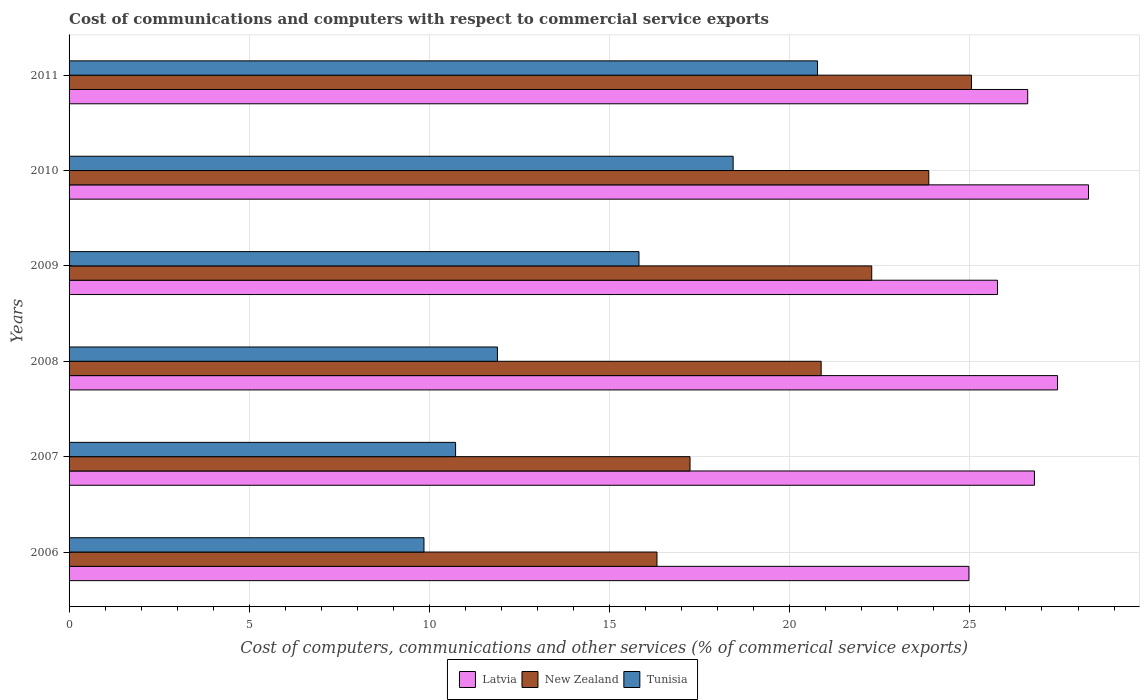How many groups of bars are there?
Your response must be concise. 6. Are the number of bars per tick equal to the number of legend labels?
Offer a very short reply. Yes. Are the number of bars on each tick of the Y-axis equal?
Your answer should be very brief. Yes. How many bars are there on the 5th tick from the top?
Provide a short and direct response. 3. What is the label of the 4th group of bars from the top?
Your answer should be compact. 2008. In how many cases, is the number of bars for a given year not equal to the number of legend labels?
Make the answer very short. 0. What is the cost of communications and computers in Tunisia in 2009?
Provide a succinct answer. 15.82. Across all years, what is the maximum cost of communications and computers in New Zealand?
Your response must be concise. 25.04. Across all years, what is the minimum cost of communications and computers in New Zealand?
Provide a succinct answer. 16.32. What is the total cost of communications and computers in Tunisia in the graph?
Provide a short and direct response. 87.48. What is the difference between the cost of communications and computers in New Zealand in 2006 and that in 2009?
Make the answer very short. -5.96. What is the difference between the cost of communications and computers in Latvia in 2011 and the cost of communications and computers in Tunisia in 2008?
Your answer should be very brief. 14.72. What is the average cost of communications and computers in New Zealand per year?
Offer a very short reply. 20.93. In the year 2009, what is the difference between the cost of communications and computers in New Zealand and cost of communications and computers in Latvia?
Offer a very short reply. -3.49. In how many years, is the cost of communications and computers in Latvia greater than 5 %?
Provide a short and direct response. 6. What is the ratio of the cost of communications and computers in Tunisia in 2006 to that in 2009?
Your answer should be compact. 0.62. What is the difference between the highest and the second highest cost of communications and computers in New Zealand?
Provide a short and direct response. 1.18. What is the difference between the highest and the lowest cost of communications and computers in Tunisia?
Provide a succinct answer. 10.92. What does the 3rd bar from the top in 2007 represents?
Make the answer very short. Latvia. What does the 3rd bar from the bottom in 2007 represents?
Keep it short and to the point. Tunisia. Is it the case that in every year, the sum of the cost of communications and computers in Latvia and cost of communications and computers in Tunisia is greater than the cost of communications and computers in New Zealand?
Give a very brief answer. Yes. Are all the bars in the graph horizontal?
Provide a short and direct response. Yes. How many years are there in the graph?
Give a very brief answer. 6. Are the values on the major ticks of X-axis written in scientific E-notation?
Provide a succinct answer. No. Does the graph contain any zero values?
Keep it short and to the point. No. Does the graph contain grids?
Offer a very short reply. Yes. Where does the legend appear in the graph?
Your response must be concise. Bottom center. How many legend labels are there?
Provide a succinct answer. 3. How are the legend labels stacked?
Offer a very short reply. Horizontal. What is the title of the graph?
Provide a succinct answer. Cost of communications and computers with respect to commercial service exports. What is the label or title of the X-axis?
Make the answer very short. Cost of computers, communications and other services (% of commerical service exports). What is the Cost of computers, communications and other services (% of commerical service exports) of Latvia in 2006?
Ensure brevity in your answer.  24.97. What is the Cost of computers, communications and other services (% of commerical service exports) of New Zealand in 2006?
Offer a terse response. 16.32. What is the Cost of computers, communications and other services (% of commerical service exports) in Tunisia in 2006?
Your answer should be compact. 9.85. What is the Cost of computers, communications and other services (% of commerical service exports) of Latvia in 2007?
Give a very brief answer. 26.79. What is the Cost of computers, communications and other services (% of commerical service exports) of New Zealand in 2007?
Provide a succinct answer. 17.23. What is the Cost of computers, communications and other services (% of commerical service exports) of Tunisia in 2007?
Offer a very short reply. 10.73. What is the Cost of computers, communications and other services (% of commerical service exports) of Latvia in 2008?
Offer a very short reply. 27.43. What is the Cost of computers, communications and other services (% of commerical service exports) in New Zealand in 2008?
Keep it short and to the point. 20.87. What is the Cost of computers, communications and other services (% of commerical service exports) of Tunisia in 2008?
Your answer should be very brief. 11.89. What is the Cost of computers, communications and other services (% of commerical service exports) in Latvia in 2009?
Your answer should be very brief. 25.77. What is the Cost of computers, communications and other services (% of commerical service exports) of New Zealand in 2009?
Provide a succinct answer. 22.28. What is the Cost of computers, communications and other services (% of commerical service exports) of Tunisia in 2009?
Give a very brief answer. 15.82. What is the Cost of computers, communications and other services (% of commerical service exports) in Latvia in 2010?
Make the answer very short. 28.29. What is the Cost of computers, communications and other services (% of commerical service exports) of New Zealand in 2010?
Offer a terse response. 23.86. What is the Cost of computers, communications and other services (% of commerical service exports) in Tunisia in 2010?
Offer a very short reply. 18.43. What is the Cost of computers, communications and other services (% of commerical service exports) of Latvia in 2011?
Give a very brief answer. 26.6. What is the Cost of computers, communications and other services (% of commerical service exports) in New Zealand in 2011?
Make the answer very short. 25.04. What is the Cost of computers, communications and other services (% of commerical service exports) of Tunisia in 2011?
Your answer should be very brief. 20.77. Across all years, what is the maximum Cost of computers, communications and other services (% of commerical service exports) in Latvia?
Your answer should be compact. 28.29. Across all years, what is the maximum Cost of computers, communications and other services (% of commerical service exports) in New Zealand?
Provide a succinct answer. 25.04. Across all years, what is the maximum Cost of computers, communications and other services (% of commerical service exports) of Tunisia?
Offer a very short reply. 20.77. Across all years, what is the minimum Cost of computers, communications and other services (% of commerical service exports) of Latvia?
Make the answer very short. 24.97. Across all years, what is the minimum Cost of computers, communications and other services (% of commerical service exports) in New Zealand?
Offer a terse response. 16.32. Across all years, what is the minimum Cost of computers, communications and other services (% of commerical service exports) in Tunisia?
Ensure brevity in your answer.  9.85. What is the total Cost of computers, communications and other services (% of commerical service exports) of Latvia in the graph?
Offer a very short reply. 159.86. What is the total Cost of computers, communications and other services (% of commerical service exports) in New Zealand in the graph?
Offer a terse response. 125.6. What is the total Cost of computers, communications and other services (% of commerical service exports) in Tunisia in the graph?
Provide a succinct answer. 87.48. What is the difference between the Cost of computers, communications and other services (% of commerical service exports) in Latvia in 2006 and that in 2007?
Your response must be concise. -1.82. What is the difference between the Cost of computers, communications and other services (% of commerical service exports) of New Zealand in 2006 and that in 2007?
Provide a succinct answer. -0.92. What is the difference between the Cost of computers, communications and other services (% of commerical service exports) in Tunisia in 2006 and that in 2007?
Offer a very short reply. -0.88. What is the difference between the Cost of computers, communications and other services (% of commerical service exports) in Latvia in 2006 and that in 2008?
Keep it short and to the point. -2.46. What is the difference between the Cost of computers, communications and other services (% of commerical service exports) of New Zealand in 2006 and that in 2008?
Ensure brevity in your answer.  -4.56. What is the difference between the Cost of computers, communications and other services (% of commerical service exports) in Tunisia in 2006 and that in 2008?
Offer a terse response. -2.04. What is the difference between the Cost of computers, communications and other services (% of commerical service exports) in Latvia in 2006 and that in 2009?
Provide a succinct answer. -0.79. What is the difference between the Cost of computers, communications and other services (% of commerical service exports) in New Zealand in 2006 and that in 2009?
Make the answer very short. -5.96. What is the difference between the Cost of computers, communications and other services (% of commerical service exports) of Tunisia in 2006 and that in 2009?
Your answer should be very brief. -5.97. What is the difference between the Cost of computers, communications and other services (% of commerical service exports) of Latvia in 2006 and that in 2010?
Your answer should be compact. -3.32. What is the difference between the Cost of computers, communications and other services (% of commerical service exports) in New Zealand in 2006 and that in 2010?
Offer a terse response. -7.54. What is the difference between the Cost of computers, communications and other services (% of commerical service exports) in Tunisia in 2006 and that in 2010?
Provide a succinct answer. -8.58. What is the difference between the Cost of computers, communications and other services (% of commerical service exports) of Latvia in 2006 and that in 2011?
Your answer should be compact. -1.63. What is the difference between the Cost of computers, communications and other services (% of commerical service exports) in New Zealand in 2006 and that in 2011?
Your answer should be very brief. -8.73. What is the difference between the Cost of computers, communications and other services (% of commerical service exports) of Tunisia in 2006 and that in 2011?
Your answer should be compact. -10.92. What is the difference between the Cost of computers, communications and other services (% of commerical service exports) of Latvia in 2007 and that in 2008?
Make the answer very short. -0.64. What is the difference between the Cost of computers, communications and other services (% of commerical service exports) in New Zealand in 2007 and that in 2008?
Make the answer very short. -3.64. What is the difference between the Cost of computers, communications and other services (% of commerical service exports) of Tunisia in 2007 and that in 2008?
Your response must be concise. -1.16. What is the difference between the Cost of computers, communications and other services (% of commerical service exports) of Latvia in 2007 and that in 2009?
Make the answer very short. 1.03. What is the difference between the Cost of computers, communications and other services (% of commerical service exports) of New Zealand in 2007 and that in 2009?
Your answer should be compact. -5.04. What is the difference between the Cost of computers, communications and other services (% of commerical service exports) of Tunisia in 2007 and that in 2009?
Your answer should be compact. -5.09. What is the difference between the Cost of computers, communications and other services (% of commerical service exports) of Latvia in 2007 and that in 2010?
Ensure brevity in your answer.  -1.5. What is the difference between the Cost of computers, communications and other services (% of commerical service exports) of New Zealand in 2007 and that in 2010?
Keep it short and to the point. -6.63. What is the difference between the Cost of computers, communications and other services (% of commerical service exports) of Tunisia in 2007 and that in 2010?
Your answer should be compact. -7.7. What is the difference between the Cost of computers, communications and other services (% of commerical service exports) of Latvia in 2007 and that in 2011?
Ensure brevity in your answer.  0.19. What is the difference between the Cost of computers, communications and other services (% of commerical service exports) in New Zealand in 2007 and that in 2011?
Give a very brief answer. -7.81. What is the difference between the Cost of computers, communications and other services (% of commerical service exports) of Tunisia in 2007 and that in 2011?
Keep it short and to the point. -10.04. What is the difference between the Cost of computers, communications and other services (% of commerical service exports) in Latvia in 2008 and that in 2009?
Provide a succinct answer. 1.67. What is the difference between the Cost of computers, communications and other services (% of commerical service exports) in New Zealand in 2008 and that in 2009?
Give a very brief answer. -1.4. What is the difference between the Cost of computers, communications and other services (% of commerical service exports) of Tunisia in 2008 and that in 2009?
Make the answer very short. -3.93. What is the difference between the Cost of computers, communications and other services (% of commerical service exports) in Latvia in 2008 and that in 2010?
Keep it short and to the point. -0.86. What is the difference between the Cost of computers, communications and other services (% of commerical service exports) in New Zealand in 2008 and that in 2010?
Make the answer very short. -2.99. What is the difference between the Cost of computers, communications and other services (% of commerical service exports) in Tunisia in 2008 and that in 2010?
Offer a terse response. -6.54. What is the difference between the Cost of computers, communications and other services (% of commerical service exports) of Latvia in 2008 and that in 2011?
Your response must be concise. 0.83. What is the difference between the Cost of computers, communications and other services (% of commerical service exports) of New Zealand in 2008 and that in 2011?
Ensure brevity in your answer.  -4.17. What is the difference between the Cost of computers, communications and other services (% of commerical service exports) of Tunisia in 2008 and that in 2011?
Give a very brief answer. -8.88. What is the difference between the Cost of computers, communications and other services (% of commerical service exports) in Latvia in 2009 and that in 2010?
Offer a very short reply. -2.53. What is the difference between the Cost of computers, communications and other services (% of commerical service exports) of New Zealand in 2009 and that in 2010?
Keep it short and to the point. -1.58. What is the difference between the Cost of computers, communications and other services (% of commerical service exports) in Tunisia in 2009 and that in 2010?
Give a very brief answer. -2.61. What is the difference between the Cost of computers, communications and other services (% of commerical service exports) of Latvia in 2009 and that in 2011?
Keep it short and to the point. -0.84. What is the difference between the Cost of computers, communications and other services (% of commerical service exports) in New Zealand in 2009 and that in 2011?
Your answer should be very brief. -2.77. What is the difference between the Cost of computers, communications and other services (% of commerical service exports) of Tunisia in 2009 and that in 2011?
Your response must be concise. -4.95. What is the difference between the Cost of computers, communications and other services (% of commerical service exports) of Latvia in 2010 and that in 2011?
Your response must be concise. 1.69. What is the difference between the Cost of computers, communications and other services (% of commerical service exports) of New Zealand in 2010 and that in 2011?
Your answer should be very brief. -1.18. What is the difference between the Cost of computers, communications and other services (% of commerical service exports) of Tunisia in 2010 and that in 2011?
Make the answer very short. -2.34. What is the difference between the Cost of computers, communications and other services (% of commerical service exports) in Latvia in 2006 and the Cost of computers, communications and other services (% of commerical service exports) in New Zealand in 2007?
Provide a short and direct response. 7.74. What is the difference between the Cost of computers, communications and other services (% of commerical service exports) in Latvia in 2006 and the Cost of computers, communications and other services (% of commerical service exports) in Tunisia in 2007?
Offer a terse response. 14.25. What is the difference between the Cost of computers, communications and other services (% of commerical service exports) in New Zealand in 2006 and the Cost of computers, communications and other services (% of commerical service exports) in Tunisia in 2007?
Your response must be concise. 5.59. What is the difference between the Cost of computers, communications and other services (% of commerical service exports) in Latvia in 2006 and the Cost of computers, communications and other services (% of commerical service exports) in New Zealand in 2008?
Make the answer very short. 4.1. What is the difference between the Cost of computers, communications and other services (% of commerical service exports) in Latvia in 2006 and the Cost of computers, communications and other services (% of commerical service exports) in Tunisia in 2008?
Keep it short and to the point. 13.09. What is the difference between the Cost of computers, communications and other services (% of commerical service exports) of New Zealand in 2006 and the Cost of computers, communications and other services (% of commerical service exports) of Tunisia in 2008?
Give a very brief answer. 4.43. What is the difference between the Cost of computers, communications and other services (% of commerical service exports) of Latvia in 2006 and the Cost of computers, communications and other services (% of commerical service exports) of New Zealand in 2009?
Ensure brevity in your answer.  2.7. What is the difference between the Cost of computers, communications and other services (% of commerical service exports) in Latvia in 2006 and the Cost of computers, communications and other services (% of commerical service exports) in Tunisia in 2009?
Offer a very short reply. 9.16. What is the difference between the Cost of computers, communications and other services (% of commerical service exports) of New Zealand in 2006 and the Cost of computers, communications and other services (% of commerical service exports) of Tunisia in 2009?
Offer a very short reply. 0.5. What is the difference between the Cost of computers, communications and other services (% of commerical service exports) in Latvia in 2006 and the Cost of computers, communications and other services (% of commerical service exports) in New Zealand in 2010?
Make the answer very short. 1.11. What is the difference between the Cost of computers, communications and other services (% of commerical service exports) in Latvia in 2006 and the Cost of computers, communications and other services (% of commerical service exports) in Tunisia in 2010?
Provide a succinct answer. 6.54. What is the difference between the Cost of computers, communications and other services (% of commerical service exports) in New Zealand in 2006 and the Cost of computers, communications and other services (% of commerical service exports) in Tunisia in 2010?
Keep it short and to the point. -2.11. What is the difference between the Cost of computers, communications and other services (% of commerical service exports) in Latvia in 2006 and the Cost of computers, communications and other services (% of commerical service exports) in New Zealand in 2011?
Keep it short and to the point. -0.07. What is the difference between the Cost of computers, communications and other services (% of commerical service exports) of Latvia in 2006 and the Cost of computers, communications and other services (% of commerical service exports) of Tunisia in 2011?
Provide a succinct answer. 4.2. What is the difference between the Cost of computers, communications and other services (% of commerical service exports) in New Zealand in 2006 and the Cost of computers, communications and other services (% of commerical service exports) in Tunisia in 2011?
Your answer should be compact. -4.46. What is the difference between the Cost of computers, communications and other services (% of commerical service exports) of Latvia in 2007 and the Cost of computers, communications and other services (% of commerical service exports) of New Zealand in 2008?
Offer a terse response. 5.92. What is the difference between the Cost of computers, communications and other services (% of commerical service exports) of Latvia in 2007 and the Cost of computers, communications and other services (% of commerical service exports) of Tunisia in 2008?
Offer a terse response. 14.9. What is the difference between the Cost of computers, communications and other services (% of commerical service exports) in New Zealand in 2007 and the Cost of computers, communications and other services (% of commerical service exports) in Tunisia in 2008?
Offer a terse response. 5.35. What is the difference between the Cost of computers, communications and other services (% of commerical service exports) of Latvia in 2007 and the Cost of computers, communications and other services (% of commerical service exports) of New Zealand in 2009?
Provide a succinct answer. 4.52. What is the difference between the Cost of computers, communications and other services (% of commerical service exports) of Latvia in 2007 and the Cost of computers, communications and other services (% of commerical service exports) of Tunisia in 2009?
Offer a terse response. 10.98. What is the difference between the Cost of computers, communications and other services (% of commerical service exports) of New Zealand in 2007 and the Cost of computers, communications and other services (% of commerical service exports) of Tunisia in 2009?
Provide a succinct answer. 1.42. What is the difference between the Cost of computers, communications and other services (% of commerical service exports) in Latvia in 2007 and the Cost of computers, communications and other services (% of commerical service exports) in New Zealand in 2010?
Your response must be concise. 2.93. What is the difference between the Cost of computers, communications and other services (% of commerical service exports) in Latvia in 2007 and the Cost of computers, communications and other services (% of commerical service exports) in Tunisia in 2010?
Offer a terse response. 8.36. What is the difference between the Cost of computers, communications and other services (% of commerical service exports) in New Zealand in 2007 and the Cost of computers, communications and other services (% of commerical service exports) in Tunisia in 2010?
Ensure brevity in your answer.  -1.2. What is the difference between the Cost of computers, communications and other services (% of commerical service exports) of Latvia in 2007 and the Cost of computers, communications and other services (% of commerical service exports) of New Zealand in 2011?
Offer a terse response. 1.75. What is the difference between the Cost of computers, communications and other services (% of commerical service exports) in Latvia in 2007 and the Cost of computers, communications and other services (% of commerical service exports) in Tunisia in 2011?
Offer a terse response. 6.02. What is the difference between the Cost of computers, communications and other services (% of commerical service exports) in New Zealand in 2007 and the Cost of computers, communications and other services (% of commerical service exports) in Tunisia in 2011?
Give a very brief answer. -3.54. What is the difference between the Cost of computers, communications and other services (% of commerical service exports) of Latvia in 2008 and the Cost of computers, communications and other services (% of commerical service exports) of New Zealand in 2009?
Offer a terse response. 5.16. What is the difference between the Cost of computers, communications and other services (% of commerical service exports) in Latvia in 2008 and the Cost of computers, communications and other services (% of commerical service exports) in Tunisia in 2009?
Offer a very short reply. 11.62. What is the difference between the Cost of computers, communications and other services (% of commerical service exports) in New Zealand in 2008 and the Cost of computers, communications and other services (% of commerical service exports) in Tunisia in 2009?
Provide a short and direct response. 5.06. What is the difference between the Cost of computers, communications and other services (% of commerical service exports) in Latvia in 2008 and the Cost of computers, communications and other services (% of commerical service exports) in New Zealand in 2010?
Provide a succinct answer. 3.57. What is the difference between the Cost of computers, communications and other services (% of commerical service exports) in Latvia in 2008 and the Cost of computers, communications and other services (% of commerical service exports) in Tunisia in 2010?
Keep it short and to the point. 9. What is the difference between the Cost of computers, communications and other services (% of commerical service exports) of New Zealand in 2008 and the Cost of computers, communications and other services (% of commerical service exports) of Tunisia in 2010?
Offer a terse response. 2.44. What is the difference between the Cost of computers, communications and other services (% of commerical service exports) in Latvia in 2008 and the Cost of computers, communications and other services (% of commerical service exports) in New Zealand in 2011?
Keep it short and to the point. 2.39. What is the difference between the Cost of computers, communications and other services (% of commerical service exports) in Latvia in 2008 and the Cost of computers, communications and other services (% of commerical service exports) in Tunisia in 2011?
Give a very brief answer. 6.66. What is the difference between the Cost of computers, communications and other services (% of commerical service exports) of New Zealand in 2008 and the Cost of computers, communications and other services (% of commerical service exports) of Tunisia in 2011?
Ensure brevity in your answer.  0.1. What is the difference between the Cost of computers, communications and other services (% of commerical service exports) in Latvia in 2009 and the Cost of computers, communications and other services (% of commerical service exports) in New Zealand in 2010?
Provide a short and direct response. 1.91. What is the difference between the Cost of computers, communications and other services (% of commerical service exports) in Latvia in 2009 and the Cost of computers, communications and other services (% of commerical service exports) in Tunisia in 2010?
Your response must be concise. 7.34. What is the difference between the Cost of computers, communications and other services (% of commerical service exports) of New Zealand in 2009 and the Cost of computers, communications and other services (% of commerical service exports) of Tunisia in 2010?
Give a very brief answer. 3.85. What is the difference between the Cost of computers, communications and other services (% of commerical service exports) of Latvia in 2009 and the Cost of computers, communications and other services (% of commerical service exports) of New Zealand in 2011?
Offer a terse response. 0.72. What is the difference between the Cost of computers, communications and other services (% of commerical service exports) of Latvia in 2009 and the Cost of computers, communications and other services (% of commerical service exports) of Tunisia in 2011?
Your answer should be very brief. 5. What is the difference between the Cost of computers, communications and other services (% of commerical service exports) of New Zealand in 2009 and the Cost of computers, communications and other services (% of commerical service exports) of Tunisia in 2011?
Offer a terse response. 1.5. What is the difference between the Cost of computers, communications and other services (% of commerical service exports) in Latvia in 2010 and the Cost of computers, communications and other services (% of commerical service exports) in New Zealand in 2011?
Your answer should be compact. 3.25. What is the difference between the Cost of computers, communications and other services (% of commerical service exports) of Latvia in 2010 and the Cost of computers, communications and other services (% of commerical service exports) of Tunisia in 2011?
Provide a succinct answer. 7.52. What is the difference between the Cost of computers, communications and other services (% of commerical service exports) in New Zealand in 2010 and the Cost of computers, communications and other services (% of commerical service exports) in Tunisia in 2011?
Provide a short and direct response. 3.09. What is the average Cost of computers, communications and other services (% of commerical service exports) in Latvia per year?
Your answer should be very brief. 26.64. What is the average Cost of computers, communications and other services (% of commerical service exports) of New Zealand per year?
Provide a short and direct response. 20.93. What is the average Cost of computers, communications and other services (% of commerical service exports) in Tunisia per year?
Your response must be concise. 14.58. In the year 2006, what is the difference between the Cost of computers, communications and other services (% of commerical service exports) of Latvia and Cost of computers, communications and other services (% of commerical service exports) of New Zealand?
Ensure brevity in your answer.  8.66. In the year 2006, what is the difference between the Cost of computers, communications and other services (% of commerical service exports) of Latvia and Cost of computers, communications and other services (% of commerical service exports) of Tunisia?
Ensure brevity in your answer.  15.12. In the year 2006, what is the difference between the Cost of computers, communications and other services (% of commerical service exports) in New Zealand and Cost of computers, communications and other services (% of commerical service exports) in Tunisia?
Offer a very short reply. 6.47. In the year 2007, what is the difference between the Cost of computers, communications and other services (% of commerical service exports) in Latvia and Cost of computers, communications and other services (% of commerical service exports) in New Zealand?
Offer a terse response. 9.56. In the year 2007, what is the difference between the Cost of computers, communications and other services (% of commerical service exports) of Latvia and Cost of computers, communications and other services (% of commerical service exports) of Tunisia?
Offer a terse response. 16.06. In the year 2007, what is the difference between the Cost of computers, communications and other services (% of commerical service exports) of New Zealand and Cost of computers, communications and other services (% of commerical service exports) of Tunisia?
Offer a very short reply. 6.51. In the year 2008, what is the difference between the Cost of computers, communications and other services (% of commerical service exports) of Latvia and Cost of computers, communications and other services (% of commerical service exports) of New Zealand?
Make the answer very short. 6.56. In the year 2008, what is the difference between the Cost of computers, communications and other services (% of commerical service exports) of Latvia and Cost of computers, communications and other services (% of commerical service exports) of Tunisia?
Keep it short and to the point. 15.54. In the year 2008, what is the difference between the Cost of computers, communications and other services (% of commerical service exports) in New Zealand and Cost of computers, communications and other services (% of commerical service exports) in Tunisia?
Offer a very short reply. 8.98. In the year 2009, what is the difference between the Cost of computers, communications and other services (% of commerical service exports) in Latvia and Cost of computers, communications and other services (% of commerical service exports) in New Zealand?
Your response must be concise. 3.49. In the year 2009, what is the difference between the Cost of computers, communications and other services (% of commerical service exports) of Latvia and Cost of computers, communications and other services (% of commerical service exports) of Tunisia?
Provide a short and direct response. 9.95. In the year 2009, what is the difference between the Cost of computers, communications and other services (% of commerical service exports) of New Zealand and Cost of computers, communications and other services (% of commerical service exports) of Tunisia?
Give a very brief answer. 6.46. In the year 2010, what is the difference between the Cost of computers, communications and other services (% of commerical service exports) of Latvia and Cost of computers, communications and other services (% of commerical service exports) of New Zealand?
Offer a terse response. 4.43. In the year 2010, what is the difference between the Cost of computers, communications and other services (% of commerical service exports) in Latvia and Cost of computers, communications and other services (% of commerical service exports) in Tunisia?
Provide a short and direct response. 9.86. In the year 2010, what is the difference between the Cost of computers, communications and other services (% of commerical service exports) of New Zealand and Cost of computers, communications and other services (% of commerical service exports) of Tunisia?
Your answer should be compact. 5.43. In the year 2011, what is the difference between the Cost of computers, communications and other services (% of commerical service exports) of Latvia and Cost of computers, communications and other services (% of commerical service exports) of New Zealand?
Your answer should be very brief. 1.56. In the year 2011, what is the difference between the Cost of computers, communications and other services (% of commerical service exports) of Latvia and Cost of computers, communications and other services (% of commerical service exports) of Tunisia?
Ensure brevity in your answer.  5.83. In the year 2011, what is the difference between the Cost of computers, communications and other services (% of commerical service exports) in New Zealand and Cost of computers, communications and other services (% of commerical service exports) in Tunisia?
Offer a terse response. 4.27. What is the ratio of the Cost of computers, communications and other services (% of commerical service exports) in Latvia in 2006 to that in 2007?
Your response must be concise. 0.93. What is the ratio of the Cost of computers, communications and other services (% of commerical service exports) of New Zealand in 2006 to that in 2007?
Make the answer very short. 0.95. What is the ratio of the Cost of computers, communications and other services (% of commerical service exports) in Tunisia in 2006 to that in 2007?
Provide a succinct answer. 0.92. What is the ratio of the Cost of computers, communications and other services (% of commerical service exports) in Latvia in 2006 to that in 2008?
Provide a succinct answer. 0.91. What is the ratio of the Cost of computers, communications and other services (% of commerical service exports) in New Zealand in 2006 to that in 2008?
Keep it short and to the point. 0.78. What is the ratio of the Cost of computers, communications and other services (% of commerical service exports) of Tunisia in 2006 to that in 2008?
Ensure brevity in your answer.  0.83. What is the ratio of the Cost of computers, communications and other services (% of commerical service exports) in Latvia in 2006 to that in 2009?
Ensure brevity in your answer.  0.97. What is the ratio of the Cost of computers, communications and other services (% of commerical service exports) in New Zealand in 2006 to that in 2009?
Give a very brief answer. 0.73. What is the ratio of the Cost of computers, communications and other services (% of commerical service exports) in Tunisia in 2006 to that in 2009?
Provide a succinct answer. 0.62. What is the ratio of the Cost of computers, communications and other services (% of commerical service exports) in Latvia in 2006 to that in 2010?
Provide a succinct answer. 0.88. What is the ratio of the Cost of computers, communications and other services (% of commerical service exports) of New Zealand in 2006 to that in 2010?
Provide a short and direct response. 0.68. What is the ratio of the Cost of computers, communications and other services (% of commerical service exports) in Tunisia in 2006 to that in 2010?
Give a very brief answer. 0.53. What is the ratio of the Cost of computers, communications and other services (% of commerical service exports) of Latvia in 2006 to that in 2011?
Keep it short and to the point. 0.94. What is the ratio of the Cost of computers, communications and other services (% of commerical service exports) in New Zealand in 2006 to that in 2011?
Provide a succinct answer. 0.65. What is the ratio of the Cost of computers, communications and other services (% of commerical service exports) in Tunisia in 2006 to that in 2011?
Ensure brevity in your answer.  0.47. What is the ratio of the Cost of computers, communications and other services (% of commerical service exports) in Latvia in 2007 to that in 2008?
Your answer should be very brief. 0.98. What is the ratio of the Cost of computers, communications and other services (% of commerical service exports) in New Zealand in 2007 to that in 2008?
Ensure brevity in your answer.  0.83. What is the ratio of the Cost of computers, communications and other services (% of commerical service exports) of Tunisia in 2007 to that in 2008?
Keep it short and to the point. 0.9. What is the ratio of the Cost of computers, communications and other services (% of commerical service exports) in Latvia in 2007 to that in 2009?
Make the answer very short. 1.04. What is the ratio of the Cost of computers, communications and other services (% of commerical service exports) of New Zealand in 2007 to that in 2009?
Ensure brevity in your answer.  0.77. What is the ratio of the Cost of computers, communications and other services (% of commerical service exports) of Tunisia in 2007 to that in 2009?
Your answer should be very brief. 0.68. What is the ratio of the Cost of computers, communications and other services (% of commerical service exports) of Latvia in 2007 to that in 2010?
Give a very brief answer. 0.95. What is the ratio of the Cost of computers, communications and other services (% of commerical service exports) of New Zealand in 2007 to that in 2010?
Provide a succinct answer. 0.72. What is the ratio of the Cost of computers, communications and other services (% of commerical service exports) of Tunisia in 2007 to that in 2010?
Offer a very short reply. 0.58. What is the ratio of the Cost of computers, communications and other services (% of commerical service exports) in Latvia in 2007 to that in 2011?
Your response must be concise. 1.01. What is the ratio of the Cost of computers, communications and other services (% of commerical service exports) in New Zealand in 2007 to that in 2011?
Provide a succinct answer. 0.69. What is the ratio of the Cost of computers, communications and other services (% of commerical service exports) in Tunisia in 2007 to that in 2011?
Give a very brief answer. 0.52. What is the ratio of the Cost of computers, communications and other services (% of commerical service exports) of Latvia in 2008 to that in 2009?
Offer a very short reply. 1.06. What is the ratio of the Cost of computers, communications and other services (% of commerical service exports) of New Zealand in 2008 to that in 2009?
Your answer should be very brief. 0.94. What is the ratio of the Cost of computers, communications and other services (% of commerical service exports) in Tunisia in 2008 to that in 2009?
Your response must be concise. 0.75. What is the ratio of the Cost of computers, communications and other services (% of commerical service exports) of Latvia in 2008 to that in 2010?
Make the answer very short. 0.97. What is the ratio of the Cost of computers, communications and other services (% of commerical service exports) in New Zealand in 2008 to that in 2010?
Make the answer very short. 0.87. What is the ratio of the Cost of computers, communications and other services (% of commerical service exports) of Tunisia in 2008 to that in 2010?
Your answer should be compact. 0.65. What is the ratio of the Cost of computers, communications and other services (% of commerical service exports) of Latvia in 2008 to that in 2011?
Your answer should be very brief. 1.03. What is the ratio of the Cost of computers, communications and other services (% of commerical service exports) in New Zealand in 2008 to that in 2011?
Give a very brief answer. 0.83. What is the ratio of the Cost of computers, communications and other services (% of commerical service exports) of Tunisia in 2008 to that in 2011?
Give a very brief answer. 0.57. What is the ratio of the Cost of computers, communications and other services (% of commerical service exports) in Latvia in 2009 to that in 2010?
Provide a short and direct response. 0.91. What is the ratio of the Cost of computers, communications and other services (% of commerical service exports) in New Zealand in 2009 to that in 2010?
Your response must be concise. 0.93. What is the ratio of the Cost of computers, communications and other services (% of commerical service exports) of Tunisia in 2009 to that in 2010?
Offer a very short reply. 0.86. What is the ratio of the Cost of computers, communications and other services (% of commerical service exports) in Latvia in 2009 to that in 2011?
Offer a very short reply. 0.97. What is the ratio of the Cost of computers, communications and other services (% of commerical service exports) of New Zealand in 2009 to that in 2011?
Keep it short and to the point. 0.89. What is the ratio of the Cost of computers, communications and other services (% of commerical service exports) in Tunisia in 2009 to that in 2011?
Provide a succinct answer. 0.76. What is the ratio of the Cost of computers, communications and other services (% of commerical service exports) in Latvia in 2010 to that in 2011?
Keep it short and to the point. 1.06. What is the ratio of the Cost of computers, communications and other services (% of commerical service exports) in New Zealand in 2010 to that in 2011?
Keep it short and to the point. 0.95. What is the ratio of the Cost of computers, communications and other services (% of commerical service exports) in Tunisia in 2010 to that in 2011?
Offer a very short reply. 0.89. What is the difference between the highest and the second highest Cost of computers, communications and other services (% of commerical service exports) in Latvia?
Offer a very short reply. 0.86. What is the difference between the highest and the second highest Cost of computers, communications and other services (% of commerical service exports) of New Zealand?
Offer a terse response. 1.18. What is the difference between the highest and the second highest Cost of computers, communications and other services (% of commerical service exports) of Tunisia?
Ensure brevity in your answer.  2.34. What is the difference between the highest and the lowest Cost of computers, communications and other services (% of commerical service exports) of Latvia?
Provide a short and direct response. 3.32. What is the difference between the highest and the lowest Cost of computers, communications and other services (% of commerical service exports) of New Zealand?
Give a very brief answer. 8.73. What is the difference between the highest and the lowest Cost of computers, communications and other services (% of commerical service exports) of Tunisia?
Your answer should be compact. 10.92. 